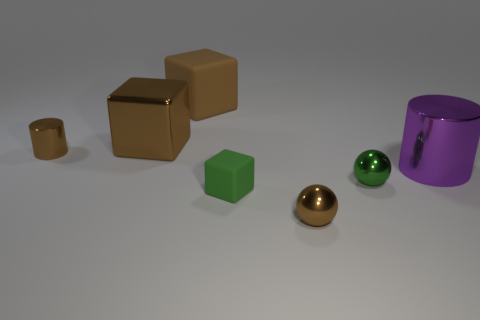The purple object that is the same material as the tiny green ball is what shape?
Offer a terse response. Cylinder. What is the cylinder that is on the left side of the tiny cube made of?
Give a very brief answer. Metal. There is a ball behind the tiny green rubber thing; does it have the same size as the brown cylinder that is on the left side of the big cylinder?
Your answer should be compact. Yes. What is the color of the tiny block?
Provide a succinct answer. Green. Does the big metal thing to the right of the small green ball have the same shape as the large brown matte thing?
Your answer should be compact. No. What material is the purple object?
Give a very brief answer. Metal. What is the shape of the other metal object that is the same size as the purple thing?
Give a very brief answer. Cube. Is there a shiny thing that has the same color as the large matte object?
Offer a very short reply. Yes. There is a large cylinder; does it have the same color as the cylinder that is on the left side of the brown matte thing?
Your answer should be compact. No. There is a metal thing that is behind the tiny cylinder behind the small brown shiny ball; what color is it?
Offer a terse response. Brown. 